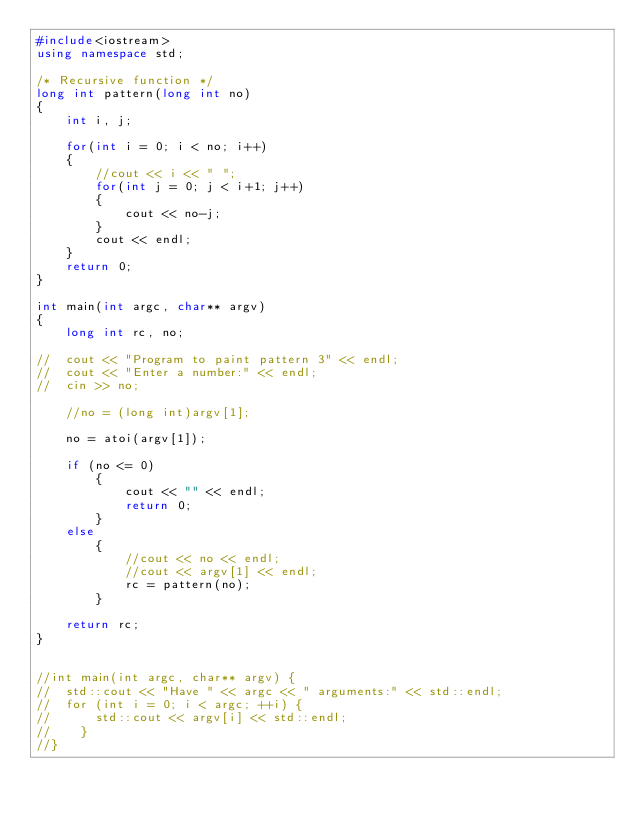Convert code to text. <code><loc_0><loc_0><loc_500><loc_500><_C++_>#include<iostream>
using namespace std;

/* Recursive function */
long int pattern(long int no)
{
	int i, j;

  	for(int i = 0; i < no; i++)
	{
		//cout << i << " ";
		for(int j = 0; j < i+1; j++)
		{
			cout << no-j;
		}
		cout << endl;
	}
	return 0;
}

int main(int argc, char** argv)
{
	long int rc, no;

//	cout << "Program to paint pattern 3" << endl;
//	cout << "Enter a number:" << endl;
//	cin >> no;

	//no = (long int)argv[1];

	no = atoi(argv[1]);

	if (no <= 0)
		{
			cout << "" << endl;
			return 0;
		} 
	else 
		{
			//cout << no << endl;
			//cout << argv[1] << endl;
			rc = pattern(no);
		}
		
	return rc;
}


//int main(int argc, char** argv) {
//  std::cout << "Have " << argc << " arguments:" << std::endl;
//  for (int i = 0; i < argc; ++i) {
//      std::cout << argv[i] << std::endl;
//    }
//}</code> 